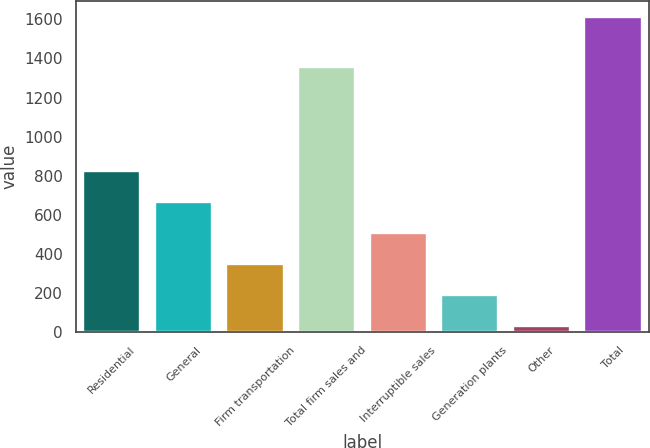Convert chart to OTSL. <chart><loc_0><loc_0><loc_500><loc_500><bar_chart><fcel>Residential<fcel>General<fcel>Firm transportation<fcel>Total firm sales and<fcel>Interruptible sales<fcel>Generation plants<fcel>Other<fcel>Total<nl><fcel>821.5<fcel>663.2<fcel>346.6<fcel>1357<fcel>504.9<fcel>188.3<fcel>30<fcel>1613<nl></chart> 